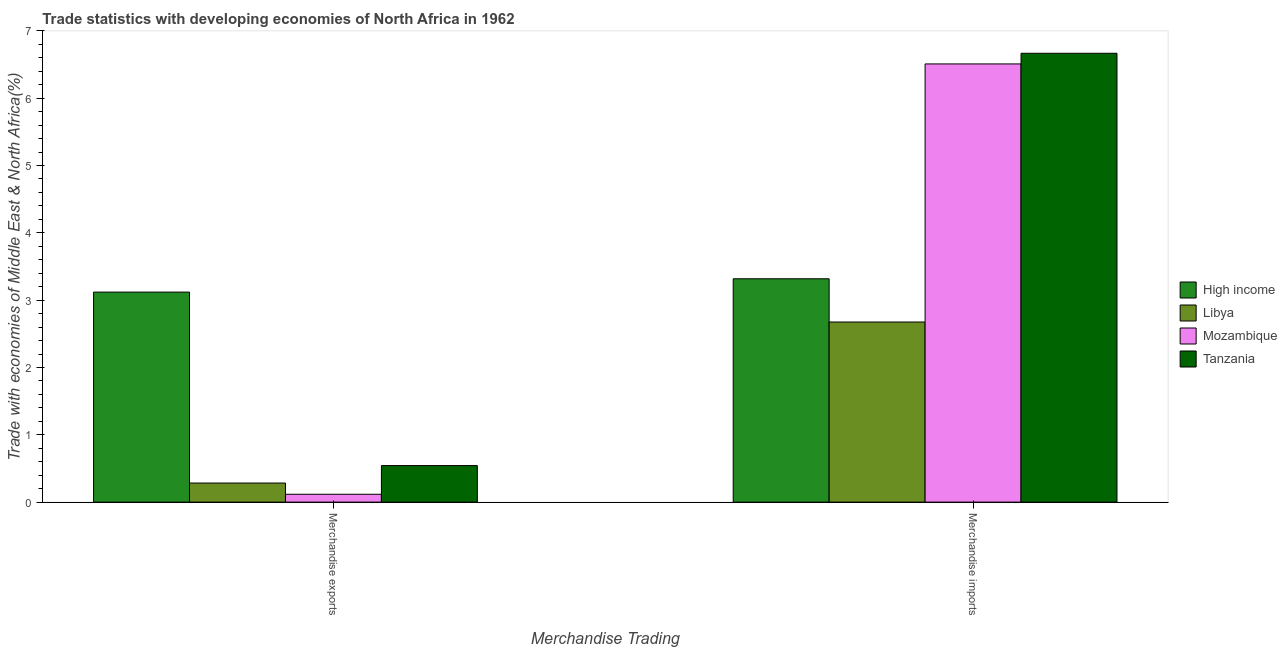Are the number of bars on each tick of the X-axis equal?
Your response must be concise. Yes. How many bars are there on the 2nd tick from the left?
Ensure brevity in your answer.  4. How many bars are there on the 1st tick from the right?
Keep it short and to the point. 4. What is the merchandise exports in Tanzania?
Make the answer very short. 0.54. Across all countries, what is the maximum merchandise exports?
Make the answer very short. 3.12. Across all countries, what is the minimum merchandise imports?
Your response must be concise. 2.68. In which country was the merchandise imports maximum?
Give a very brief answer. Tanzania. In which country was the merchandise imports minimum?
Offer a very short reply. Libya. What is the total merchandise imports in the graph?
Offer a very short reply. 19.17. What is the difference between the merchandise exports in Tanzania and that in Libya?
Ensure brevity in your answer.  0.26. What is the difference between the merchandise imports in Tanzania and the merchandise exports in High income?
Offer a very short reply. 3.55. What is the average merchandise exports per country?
Your answer should be very brief. 1.02. What is the difference between the merchandise exports and merchandise imports in High income?
Keep it short and to the point. -0.2. In how many countries, is the merchandise exports greater than 1.2 %?
Offer a terse response. 1. What is the ratio of the merchandise exports in Mozambique to that in Libya?
Offer a terse response. 0.41. In how many countries, is the merchandise exports greater than the average merchandise exports taken over all countries?
Keep it short and to the point. 1. What does the 3rd bar from the left in Merchandise imports represents?
Your answer should be very brief. Mozambique. What does the 1st bar from the right in Merchandise exports represents?
Give a very brief answer. Tanzania. How many bars are there?
Ensure brevity in your answer.  8. Are all the bars in the graph horizontal?
Offer a very short reply. No. How many countries are there in the graph?
Your answer should be very brief. 4. Are the values on the major ticks of Y-axis written in scientific E-notation?
Keep it short and to the point. No. Does the graph contain any zero values?
Give a very brief answer. No. Does the graph contain grids?
Keep it short and to the point. No. Where does the legend appear in the graph?
Give a very brief answer. Center right. How are the legend labels stacked?
Give a very brief answer. Vertical. What is the title of the graph?
Offer a terse response. Trade statistics with developing economies of North Africa in 1962. Does "Uganda" appear as one of the legend labels in the graph?
Ensure brevity in your answer.  No. What is the label or title of the X-axis?
Your answer should be very brief. Merchandise Trading. What is the label or title of the Y-axis?
Keep it short and to the point. Trade with economies of Middle East & North Africa(%). What is the Trade with economies of Middle East & North Africa(%) of High income in Merchandise exports?
Provide a succinct answer. 3.12. What is the Trade with economies of Middle East & North Africa(%) in Libya in Merchandise exports?
Your response must be concise. 0.28. What is the Trade with economies of Middle East & North Africa(%) in Mozambique in Merchandise exports?
Your response must be concise. 0.12. What is the Trade with economies of Middle East & North Africa(%) in Tanzania in Merchandise exports?
Your response must be concise. 0.54. What is the Trade with economies of Middle East & North Africa(%) of High income in Merchandise imports?
Your response must be concise. 3.32. What is the Trade with economies of Middle East & North Africa(%) in Libya in Merchandise imports?
Keep it short and to the point. 2.68. What is the Trade with economies of Middle East & North Africa(%) in Mozambique in Merchandise imports?
Keep it short and to the point. 6.51. What is the Trade with economies of Middle East & North Africa(%) of Tanzania in Merchandise imports?
Offer a very short reply. 6.67. Across all Merchandise Trading, what is the maximum Trade with economies of Middle East & North Africa(%) in High income?
Make the answer very short. 3.32. Across all Merchandise Trading, what is the maximum Trade with economies of Middle East & North Africa(%) in Libya?
Your answer should be compact. 2.68. Across all Merchandise Trading, what is the maximum Trade with economies of Middle East & North Africa(%) in Mozambique?
Your answer should be very brief. 6.51. Across all Merchandise Trading, what is the maximum Trade with economies of Middle East & North Africa(%) in Tanzania?
Make the answer very short. 6.67. Across all Merchandise Trading, what is the minimum Trade with economies of Middle East & North Africa(%) in High income?
Keep it short and to the point. 3.12. Across all Merchandise Trading, what is the minimum Trade with economies of Middle East & North Africa(%) in Libya?
Provide a short and direct response. 0.28. Across all Merchandise Trading, what is the minimum Trade with economies of Middle East & North Africa(%) of Mozambique?
Your response must be concise. 0.12. Across all Merchandise Trading, what is the minimum Trade with economies of Middle East & North Africa(%) of Tanzania?
Give a very brief answer. 0.54. What is the total Trade with economies of Middle East & North Africa(%) in High income in the graph?
Give a very brief answer. 6.44. What is the total Trade with economies of Middle East & North Africa(%) in Libya in the graph?
Offer a very short reply. 2.96. What is the total Trade with economies of Middle East & North Africa(%) of Mozambique in the graph?
Offer a very short reply. 6.62. What is the total Trade with economies of Middle East & North Africa(%) in Tanzania in the graph?
Your response must be concise. 7.21. What is the difference between the Trade with economies of Middle East & North Africa(%) in High income in Merchandise exports and that in Merchandise imports?
Your response must be concise. -0.2. What is the difference between the Trade with economies of Middle East & North Africa(%) in Libya in Merchandise exports and that in Merchandise imports?
Provide a succinct answer. -2.39. What is the difference between the Trade with economies of Middle East & North Africa(%) in Mozambique in Merchandise exports and that in Merchandise imports?
Provide a succinct answer. -6.39. What is the difference between the Trade with economies of Middle East & North Africa(%) in Tanzania in Merchandise exports and that in Merchandise imports?
Offer a terse response. -6.12. What is the difference between the Trade with economies of Middle East & North Africa(%) in High income in Merchandise exports and the Trade with economies of Middle East & North Africa(%) in Libya in Merchandise imports?
Ensure brevity in your answer.  0.44. What is the difference between the Trade with economies of Middle East & North Africa(%) in High income in Merchandise exports and the Trade with economies of Middle East & North Africa(%) in Mozambique in Merchandise imports?
Ensure brevity in your answer.  -3.39. What is the difference between the Trade with economies of Middle East & North Africa(%) of High income in Merchandise exports and the Trade with economies of Middle East & North Africa(%) of Tanzania in Merchandise imports?
Offer a very short reply. -3.55. What is the difference between the Trade with economies of Middle East & North Africa(%) in Libya in Merchandise exports and the Trade with economies of Middle East & North Africa(%) in Mozambique in Merchandise imports?
Your answer should be compact. -6.22. What is the difference between the Trade with economies of Middle East & North Africa(%) of Libya in Merchandise exports and the Trade with economies of Middle East & North Africa(%) of Tanzania in Merchandise imports?
Your answer should be very brief. -6.38. What is the difference between the Trade with economies of Middle East & North Africa(%) of Mozambique in Merchandise exports and the Trade with economies of Middle East & North Africa(%) of Tanzania in Merchandise imports?
Offer a very short reply. -6.55. What is the average Trade with economies of Middle East & North Africa(%) in High income per Merchandise Trading?
Keep it short and to the point. 3.22. What is the average Trade with economies of Middle East & North Africa(%) in Libya per Merchandise Trading?
Offer a very short reply. 1.48. What is the average Trade with economies of Middle East & North Africa(%) in Mozambique per Merchandise Trading?
Give a very brief answer. 3.31. What is the average Trade with economies of Middle East & North Africa(%) in Tanzania per Merchandise Trading?
Offer a very short reply. 3.6. What is the difference between the Trade with economies of Middle East & North Africa(%) of High income and Trade with economies of Middle East & North Africa(%) of Libya in Merchandise exports?
Your answer should be very brief. 2.84. What is the difference between the Trade with economies of Middle East & North Africa(%) of High income and Trade with economies of Middle East & North Africa(%) of Mozambique in Merchandise exports?
Offer a very short reply. 3. What is the difference between the Trade with economies of Middle East & North Africa(%) in High income and Trade with economies of Middle East & North Africa(%) in Tanzania in Merchandise exports?
Offer a terse response. 2.58. What is the difference between the Trade with economies of Middle East & North Africa(%) in Libya and Trade with economies of Middle East & North Africa(%) in Mozambique in Merchandise exports?
Make the answer very short. 0.17. What is the difference between the Trade with economies of Middle East & North Africa(%) of Libya and Trade with economies of Middle East & North Africa(%) of Tanzania in Merchandise exports?
Give a very brief answer. -0.26. What is the difference between the Trade with economies of Middle East & North Africa(%) in Mozambique and Trade with economies of Middle East & North Africa(%) in Tanzania in Merchandise exports?
Offer a very short reply. -0.43. What is the difference between the Trade with economies of Middle East & North Africa(%) of High income and Trade with economies of Middle East & North Africa(%) of Libya in Merchandise imports?
Keep it short and to the point. 0.64. What is the difference between the Trade with economies of Middle East & North Africa(%) in High income and Trade with economies of Middle East & North Africa(%) in Mozambique in Merchandise imports?
Your answer should be compact. -3.19. What is the difference between the Trade with economies of Middle East & North Africa(%) in High income and Trade with economies of Middle East & North Africa(%) in Tanzania in Merchandise imports?
Ensure brevity in your answer.  -3.35. What is the difference between the Trade with economies of Middle East & North Africa(%) in Libya and Trade with economies of Middle East & North Africa(%) in Mozambique in Merchandise imports?
Your response must be concise. -3.83. What is the difference between the Trade with economies of Middle East & North Africa(%) in Libya and Trade with economies of Middle East & North Africa(%) in Tanzania in Merchandise imports?
Keep it short and to the point. -3.99. What is the difference between the Trade with economies of Middle East & North Africa(%) in Mozambique and Trade with economies of Middle East & North Africa(%) in Tanzania in Merchandise imports?
Provide a short and direct response. -0.16. What is the ratio of the Trade with economies of Middle East & North Africa(%) of High income in Merchandise exports to that in Merchandise imports?
Your answer should be compact. 0.94. What is the ratio of the Trade with economies of Middle East & North Africa(%) in Libya in Merchandise exports to that in Merchandise imports?
Give a very brief answer. 0.11. What is the ratio of the Trade with economies of Middle East & North Africa(%) in Mozambique in Merchandise exports to that in Merchandise imports?
Your answer should be compact. 0.02. What is the ratio of the Trade with economies of Middle East & North Africa(%) of Tanzania in Merchandise exports to that in Merchandise imports?
Give a very brief answer. 0.08. What is the difference between the highest and the second highest Trade with economies of Middle East & North Africa(%) of High income?
Provide a succinct answer. 0.2. What is the difference between the highest and the second highest Trade with economies of Middle East & North Africa(%) of Libya?
Your response must be concise. 2.39. What is the difference between the highest and the second highest Trade with economies of Middle East & North Africa(%) in Mozambique?
Make the answer very short. 6.39. What is the difference between the highest and the second highest Trade with economies of Middle East & North Africa(%) in Tanzania?
Your answer should be compact. 6.12. What is the difference between the highest and the lowest Trade with economies of Middle East & North Africa(%) in High income?
Make the answer very short. 0.2. What is the difference between the highest and the lowest Trade with economies of Middle East & North Africa(%) in Libya?
Your answer should be very brief. 2.39. What is the difference between the highest and the lowest Trade with economies of Middle East & North Africa(%) of Mozambique?
Your answer should be compact. 6.39. What is the difference between the highest and the lowest Trade with economies of Middle East & North Africa(%) of Tanzania?
Provide a succinct answer. 6.12. 